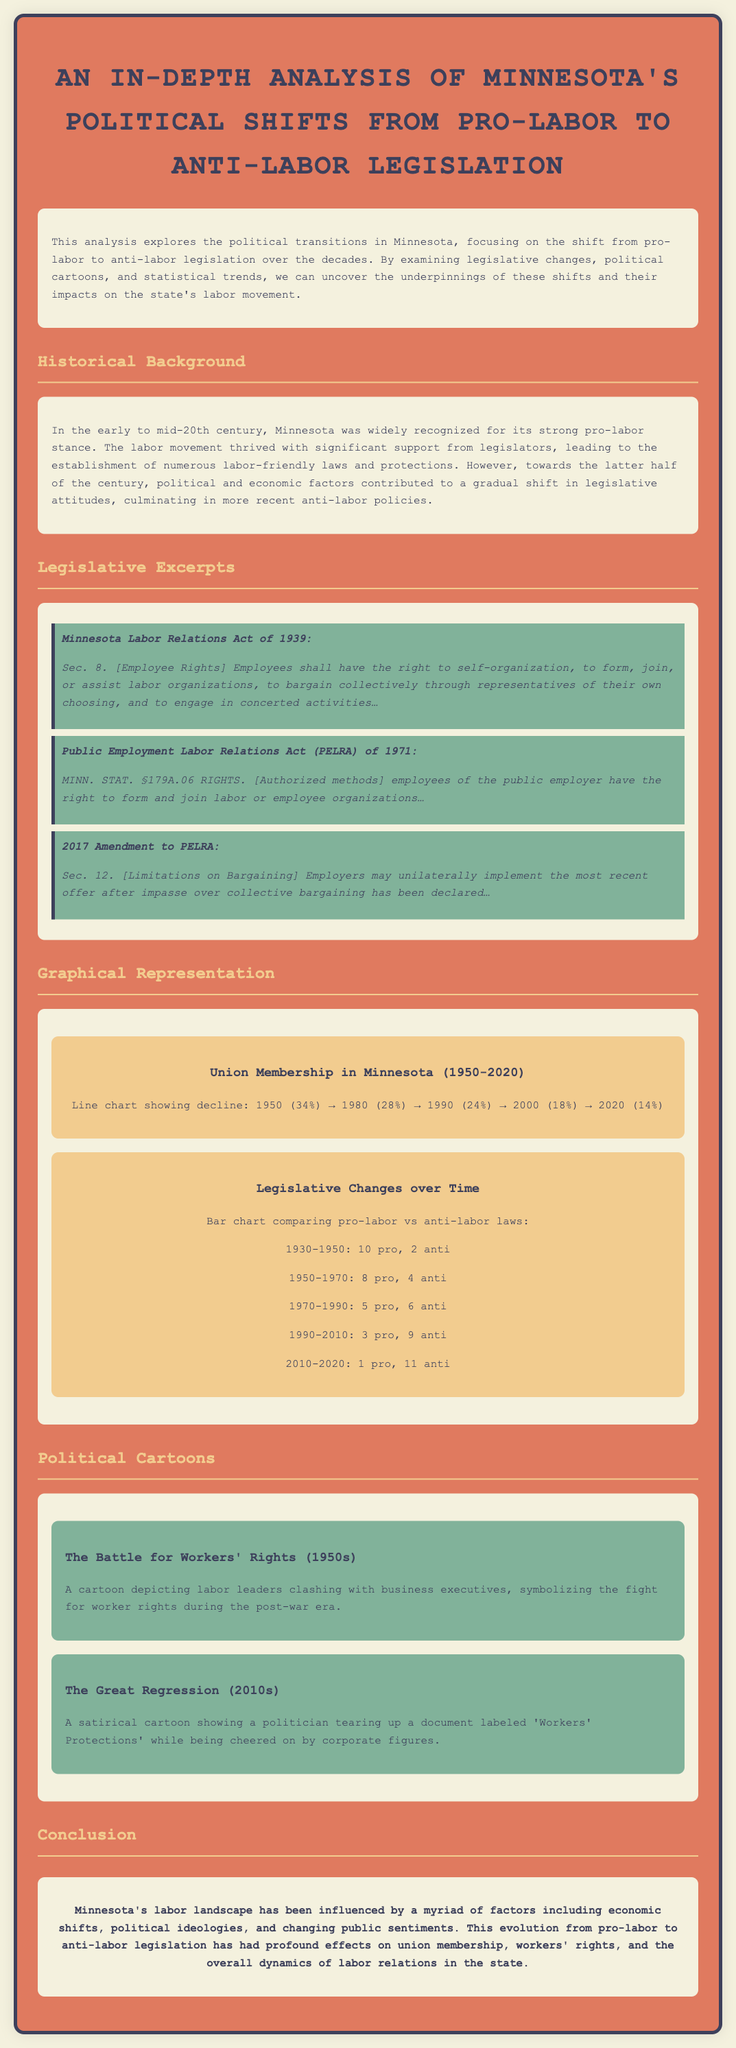what year was the Minnesota Labor Relations Act enacted? The document states that the Minnesota Labor Relations Act was enacted in 1939.
Answer: 1939 which act established employees' rights to form labor organizations? The excerpt refers to the Public Employment Labor Relations Act (PELRA) of 1971, which establishes these rights.
Answer: PELRA of 1971 how much did union membership decline from 1950 to 2020? The document shows that union membership declined from 34% in 1950 to 14% in 2020, which is a decline of 20%.
Answer: 20% how many pro-labor laws were introduced between 1990 and 2010? According to the document, 3 pro-labor laws were introduced in this period.
Answer: 3 what key theme is depicted in the cartoon titled "The Great Regression"? The cartoon symbolizes a politician tearing up workers' protections while being cheered by corporate figures, illustrating the anti-labor sentiment.
Answer: Anti-labor sentiment what is the trend in the number of anti-labor laws from 1930 to 2020? The bar chart indicates an increasing number of anti-labor laws over this period, particularly from 1990 onward.
Answer: Increasing how many anti-labor laws were introduced from 2010 to 2020? The document mentions that 11 anti-labor laws were introduced during this time frame.
Answer: 11 which decade saw the highest number of anti-labor laws according to the legislative changes? The document identifies the 2010-2020 period as having the highest number of anti-labor laws.
Answer: 2010-2020 what visual representation is used to show union membership over time? A line chart is used to depict the decline in union membership from 1950 to 2020.
Answer: Line chart 